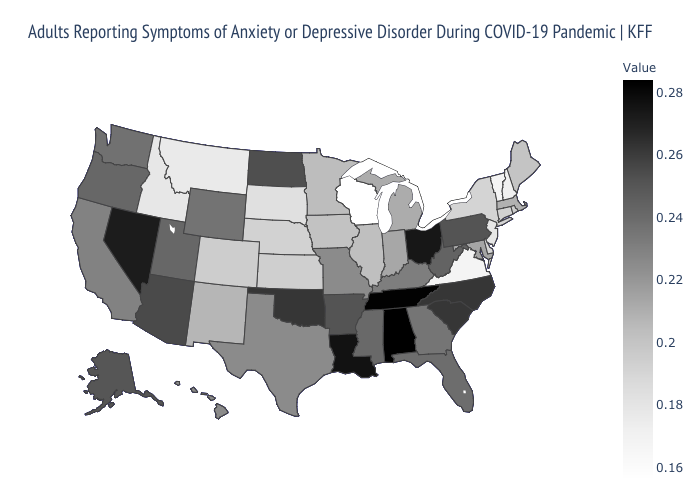Among the states that border Washington , does Idaho have the lowest value?
Write a very short answer. Yes. Is the legend a continuous bar?
Give a very brief answer. Yes. Does Pennsylvania have the lowest value in the USA?
Answer briefly. No. Among the states that border Nebraska , which have the lowest value?
Be succinct. South Dakota. Among the states that border Tennessee , does Mississippi have the highest value?
Answer briefly. No. 